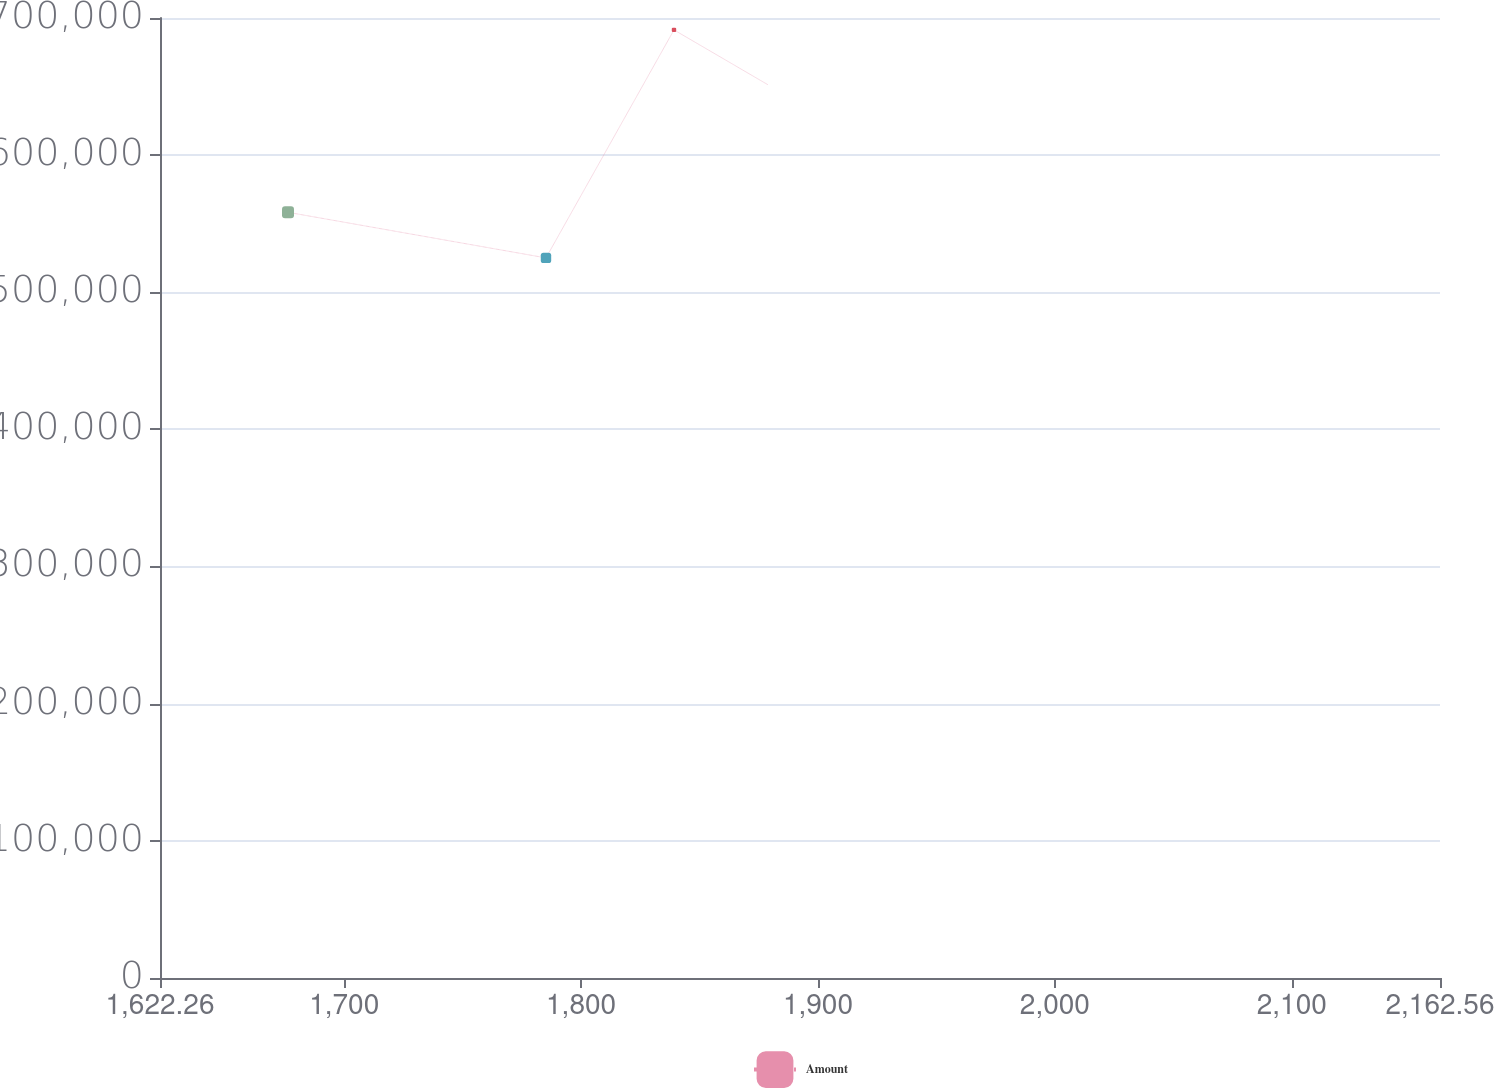Convert chart to OTSL. <chart><loc_0><loc_0><loc_500><loc_500><line_chart><ecel><fcel>Amount<nl><fcel>1676.29<fcel>558328<nl><fcel>1785.19<fcel>525080<nl><fcel>1839.22<fcel>691317<nl><fcel>1935.74<fcel>593984<nl><fcel>2216.59<fcel>541704<nl></chart> 